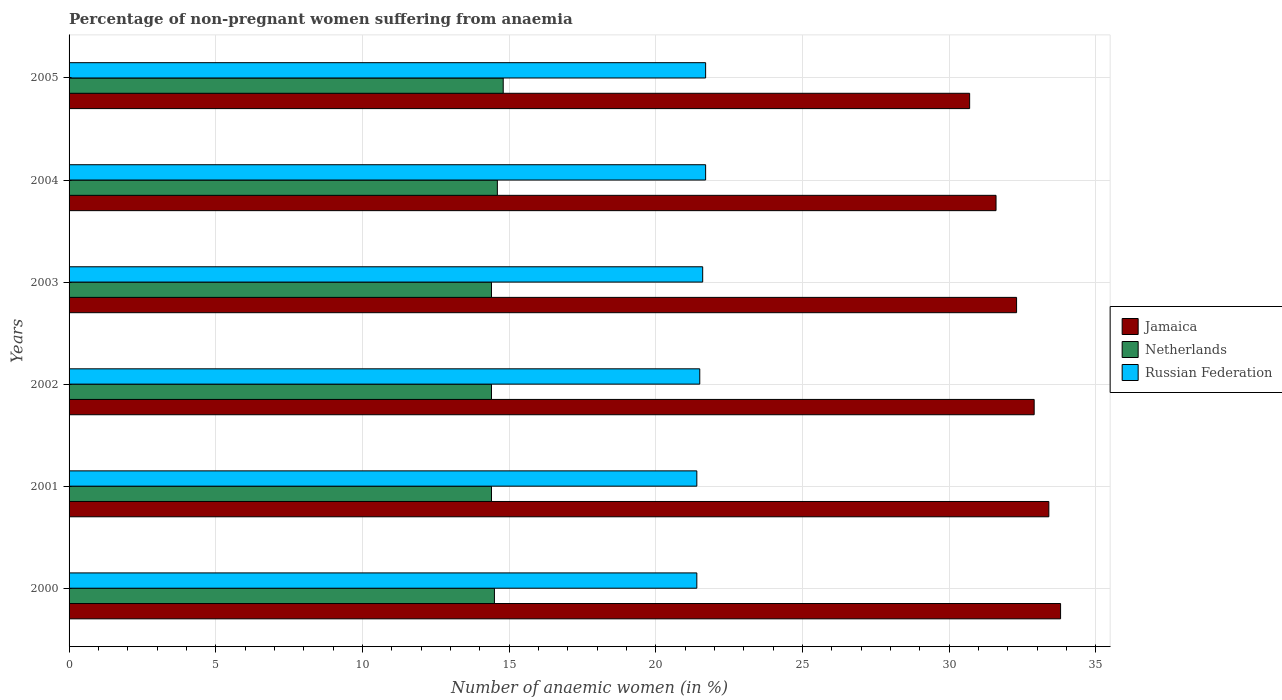How many groups of bars are there?
Provide a succinct answer. 6. What is the label of the 3rd group of bars from the top?
Give a very brief answer. 2003. In how many cases, is the number of bars for a given year not equal to the number of legend labels?
Offer a terse response. 0. What is the percentage of non-pregnant women suffering from anaemia in Jamaica in 2003?
Give a very brief answer. 32.3. Across all years, what is the minimum percentage of non-pregnant women suffering from anaemia in Russian Federation?
Your answer should be very brief. 21.4. In which year was the percentage of non-pregnant women suffering from anaemia in Netherlands maximum?
Make the answer very short. 2005. In which year was the percentage of non-pregnant women suffering from anaemia in Russian Federation minimum?
Keep it short and to the point. 2000. What is the total percentage of non-pregnant women suffering from anaemia in Netherlands in the graph?
Provide a short and direct response. 87.1. What is the difference between the percentage of non-pregnant women suffering from anaemia in Russian Federation in 2002 and that in 2005?
Offer a very short reply. -0.2. What is the difference between the percentage of non-pregnant women suffering from anaemia in Russian Federation in 2005 and the percentage of non-pregnant women suffering from anaemia in Netherlands in 2001?
Your answer should be very brief. 7.3. What is the average percentage of non-pregnant women suffering from anaemia in Russian Federation per year?
Keep it short and to the point. 21.55. In the year 2002, what is the difference between the percentage of non-pregnant women suffering from anaemia in Russian Federation and percentage of non-pregnant women suffering from anaemia in Netherlands?
Your answer should be compact. 7.1. What is the ratio of the percentage of non-pregnant women suffering from anaemia in Netherlands in 2000 to that in 2004?
Your answer should be compact. 0.99. Is the percentage of non-pregnant women suffering from anaemia in Jamaica in 2000 less than that in 2005?
Your response must be concise. No. Is the difference between the percentage of non-pregnant women suffering from anaemia in Russian Federation in 2002 and 2003 greater than the difference between the percentage of non-pregnant women suffering from anaemia in Netherlands in 2002 and 2003?
Provide a short and direct response. No. What is the difference between the highest and the second highest percentage of non-pregnant women suffering from anaemia in Netherlands?
Your response must be concise. 0.2. What is the difference between the highest and the lowest percentage of non-pregnant women suffering from anaemia in Jamaica?
Provide a succinct answer. 3.1. In how many years, is the percentage of non-pregnant women suffering from anaemia in Russian Federation greater than the average percentage of non-pregnant women suffering from anaemia in Russian Federation taken over all years?
Offer a terse response. 3. What does the 3rd bar from the bottom in 2001 represents?
Make the answer very short. Russian Federation. Is it the case that in every year, the sum of the percentage of non-pregnant women suffering from anaemia in Netherlands and percentage of non-pregnant women suffering from anaemia in Jamaica is greater than the percentage of non-pregnant women suffering from anaemia in Russian Federation?
Offer a terse response. Yes. How many bars are there?
Give a very brief answer. 18. How many years are there in the graph?
Provide a short and direct response. 6. What is the difference between two consecutive major ticks on the X-axis?
Offer a very short reply. 5. What is the title of the graph?
Your answer should be very brief. Percentage of non-pregnant women suffering from anaemia. What is the label or title of the X-axis?
Your response must be concise. Number of anaemic women (in %). What is the Number of anaemic women (in %) in Jamaica in 2000?
Provide a succinct answer. 33.8. What is the Number of anaemic women (in %) in Netherlands in 2000?
Your answer should be very brief. 14.5. What is the Number of anaemic women (in %) in Russian Federation in 2000?
Offer a very short reply. 21.4. What is the Number of anaemic women (in %) of Jamaica in 2001?
Offer a very short reply. 33.4. What is the Number of anaemic women (in %) in Russian Federation in 2001?
Give a very brief answer. 21.4. What is the Number of anaemic women (in %) of Jamaica in 2002?
Give a very brief answer. 32.9. What is the Number of anaemic women (in %) in Netherlands in 2002?
Your response must be concise. 14.4. What is the Number of anaemic women (in %) in Russian Federation in 2002?
Your answer should be compact. 21.5. What is the Number of anaemic women (in %) of Jamaica in 2003?
Ensure brevity in your answer.  32.3. What is the Number of anaemic women (in %) of Netherlands in 2003?
Your answer should be very brief. 14.4. What is the Number of anaemic women (in %) in Russian Federation in 2003?
Keep it short and to the point. 21.6. What is the Number of anaemic women (in %) of Jamaica in 2004?
Your answer should be compact. 31.6. What is the Number of anaemic women (in %) in Netherlands in 2004?
Offer a very short reply. 14.6. What is the Number of anaemic women (in %) in Russian Federation in 2004?
Provide a short and direct response. 21.7. What is the Number of anaemic women (in %) of Jamaica in 2005?
Offer a very short reply. 30.7. What is the Number of anaemic women (in %) in Netherlands in 2005?
Your response must be concise. 14.8. What is the Number of anaemic women (in %) in Russian Federation in 2005?
Your answer should be compact. 21.7. Across all years, what is the maximum Number of anaemic women (in %) of Jamaica?
Your answer should be compact. 33.8. Across all years, what is the maximum Number of anaemic women (in %) in Russian Federation?
Your answer should be compact. 21.7. Across all years, what is the minimum Number of anaemic women (in %) in Jamaica?
Provide a succinct answer. 30.7. Across all years, what is the minimum Number of anaemic women (in %) in Netherlands?
Your response must be concise. 14.4. Across all years, what is the minimum Number of anaemic women (in %) in Russian Federation?
Your answer should be very brief. 21.4. What is the total Number of anaemic women (in %) in Jamaica in the graph?
Make the answer very short. 194.7. What is the total Number of anaemic women (in %) of Netherlands in the graph?
Give a very brief answer. 87.1. What is the total Number of anaemic women (in %) in Russian Federation in the graph?
Your answer should be compact. 129.3. What is the difference between the Number of anaemic women (in %) in Russian Federation in 2000 and that in 2001?
Keep it short and to the point. 0. What is the difference between the Number of anaemic women (in %) in Jamaica in 2000 and that in 2003?
Your answer should be very brief. 1.5. What is the difference between the Number of anaemic women (in %) in Netherlands in 2000 and that in 2003?
Offer a terse response. 0.1. What is the difference between the Number of anaemic women (in %) of Jamaica in 2000 and that in 2004?
Provide a short and direct response. 2.2. What is the difference between the Number of anaemic women (in %) of Netherlands in 2000 and that in 2004?
Ensure brevity in your answer.  -0.1. What is the difference between the Number of anaemic women (in %) of Russian Federation in 2000 and that in 2004?
Offer a very short reply. -0.3. What is the difference between the Number of anaemic women (in %) of Russian Federation in 2000 and that in 2005?
Offer a terse response. -0.3. What is the difference between the Number of anaemic women (in %) of Jamaica in 2001 and that in 2002?
Your answer should be very brief. 0.5. What is the difference between the Number of anaemic women (in %) of Netherlands in 2001 and that in 2002?
Provide a short and direct response. 0. What is the difference between the Number of anaemic women (in %) in Netherlands in 2001 and that in 2003?
Offer a very short reply. 0. What is the difference between the Number of anaemic women (in %) of Russian Federation in 2001 and that in 2003?
Give a very brief answer. -0.2. What is the difference between the Number of anaemic women (in %) of Jamaica in 2001 and that in 2004?
Your response must be concise. 1.8. What is the difference between the Number of anaemic women (in %) in Netherlands in 2001 and that in 2004?
Ensure brevity in your answer.  -0.2. What is the difference between the Number of anaemic women (in %) of Russian Federation in 2001 and that in 2004?
Provide a short and direct response. -0.3. What is the difference between the Number of anaemic women (in %) of Jamaica in 2001 and that in 2005?
Offer a very short reply. 2.7. What is the difference between the Number of anaemic women (in %) in Netherlands in 2001 and that in 2005?
Offer a terse response. -0.4. What is the difference between the Number of anaemic women (in %) of Jamaica in 2002 and that in 2004?
Your answer should be very brief. 1.3. What is the difference between the Number of anaemic women (in %) of Jamaica in 2002 and that in 2005?
Your answer should be very brief. 2.2. What is the difference between the Number of anaemic women (in %) in Jamaica in 2003 and that in 2004?
Your answer should be very brief. 0.7. What is the difference between the Number of anaemic women (in %) in Russian Federation in 2003 and that in 2004?
Keep it short and to the point. -0.1. What is the difference between the Number of anaemic women (in %) in Jamaica in 2003 and that in 2005?
Your answer should be compact. 1.6. What is the difference between the Number of anaemic women (in %) in Netherlands in 2003 and that in 2005?
Your answer should be compact. -0.4. What is the difference between the Number of anaemic women (in %) of Jamaica in 2004 and that in 2005?
Keep it short and to the point. 0.9. What is the difference between the Number of anaemic women (in %) in Netherlands in 2004 and that in 2005?
Ensure brevity in your answer.  -0.2. What is the difference between the Number of anaemic women (in %) in Russian Federation in 2004 and that in 2005?
Offer a terse response. 0. What is the difference between the Number of anaemic women (in %) of Jamaica in 2000 and the Number of anaemic women (in %) of Netherlands in 2001?
Make the answer very short. 19.4. What is the difference between the Number of anaemic women (in %) in Jamaica in 2000 and the Number of anaemic women (in %) in Russian Federation in 2001?
Give a very brief answer. 12.4. What is the difference between the Number of anaemic women (in %) in Netherlands in 2000 and the Number of anaemic women (in %) in Russian Federation in 2001?
Give a very brief answer. -6.9. What is the difference between the Number of anaemic women (in %) in Jamaica in 2000 and the Number of anaemic women (in %) in Russian Federation in 2002?
Provide a short and direct response. 12.3. What is the difference between the Number of anaemic women (in %) of Jamaica in 2000 and the Number of anaemic women (in %) of Russian Federation in 2003?
Your answer should be compact. 12.2. What is the difference between the Number of anaemic women (in %) in Netherlands in 2000 and the Number of anaemic women (in %) in Russian Federation in 2003?
Make the answer very short. -7.1. What is the difference between the Number of anaemic women (in %) of Jamaica in 2000 and the Number of anaemic women (in %) of Netherlands in 2004?
Make the answer very short. 19.2. What is the difference between the Number of anaemic women (in %) of Jamaica in 2000 and the Number of anaemic women (in %) of Russian Federation in 2005?
Your answer should be compact. 12.1. What is the difference between the Number of anaemic women (in %) of Netherlands in 2000 and the Number of anaemic women (in %) of Russian Federation in 2005?
Ensure brevity in your answer.  -7.2. What is the difference between the Number of anaemic women (in %) in Jamaica in 2001 and the Number of anaemic women (in %) in Russian Federation in 2002?
Provide a short and direct response. 11.9. What is the difference between the Number of anaemic women (in %) in Jamaica in 2001 and the Number of anaemic women (in %) in Russian Federation in 2003?
Make the answer very short. 11.8. What is the difference between the Number of anaemic women (in %) of Netherlands in 2001 and the Number of anaemic women (in %) of Russian Federation in 2003?
Your answer should be very brief. -7.2. What is the difference between the Number of anaemic women (in %) in Jamaica in 2001 and the Number of anaemic women (in %) in Russian Federation in 2004?
Provide a short and direct response. 11.7. What is the difference between the Number of anaemic women (in %) of Jamaica in 2001 and the Number of anaemic women (in %) of Netherlands in 2005?
Your answer should be very brief. 18.6. What is the difference between the Number of anaemic women (in %) in Jamaica in 2001 and the Number of anaemic women (in %) in Russian Federation in 2005?
Provide a succinct answer. 11.7. What is the difference between the Number of anaemic women (in %) in Netherlands in 2001 and the Number of anaemic women (in %) in Russian Federation in 2005?
Ensure brevity in your answer.  -7.3. What is the difference between the Number of anaemic women (in %) in Jamaica in 2002 and the Number of anaemic women (in %) in Netherlands in 2003?
Keep it short and to the point. 18.5. What is the difference between the Number of anaemic women (in %) in Jamaica in 2002 and the Number of anaemic women (in %) in Russian Federation in 2003?
Give a very brief answer. 11.3. What is the difference between the Number of anaemic women (in %) of Netherlands in 2002 and the Number of anaemic women (in %) of Russian Federation in 2003?
Your answer should be compact. -7.2. What is the difference between the Number of anaemic women (in %) in Jamaica in 2002 and the Number of anaemic women (in %) in Netherlands in 2004?
Provide a short and direct response. 18.3. What is the difference between the Number of anaemic women (in %) in Jamaica in 2002 and the Number of anaemic women (in %) in Russian Federation in 2004?
Make the answer very short. 11.2. What is the difference between the Number of anaemic women (in %) of Netherlands in 2002 and the Number of anaemic women (in %) of Russian Federation in 2004?
Offer a terse response. -7.3. What is the difference between the Number of anaemic women (in %) of Netherlands in 2002 and the Number of anaemic women (in %) of Russian Federation in 2005?
Offer a terse response. -7.3. What is the difference between the Number of anaemic women (in %) of Jamaica in 2003 and the Number of anaemic women (in %) of Russian Federation in 2005?
Offer a very short reply. 10.6. What is the difference between the Number of anaemic women (in %) in Netherlands in 2003 and the Number of anaemic women (in %) in Russian Federation in 2005?
Your answer should be very brief. -7.3. What is the difference between the Number of anaemic women (in %) in Jamaica in 2004 and the Number of anaemic women (in %) in Netherlands in 2005?
Ensure brevity in your answer.  16.8. What is the difference between the Number of anaemic women (in %) of Netherlands in 2004 and the Number of anaemic women (in %) of Russian Federation in 2005?
Offer a terse response. -7.1. What is the average Number of anaemic women (in %) in Jamaica per year?
Give a very brief answer. 32.45. What is the average Number of anaemic women (in %) of Netherlands per year?
Make the answer very short. 14.52. What is the average Number of anaemic women (in %) of Russian Federation per year?
Your response must be concise. 21.55. In the year 2000, what is the difference between the Number of anaemic women (in %) of Jamaica and Number of anaemic women (in %) of Netherlands?
Offer a terse response. 19.3. In the year 2000, what is the difference between the Number of anaemic women (in %) of Netherlands and Number of anaemic women (in %) of Russian Federation?
Ensure brevity in your answer.  -6.9. In the year 2001, what is the difference between the Number of anaemic women (in %) of Jamaica and Number of anaemic women (in %) of Russian Federation?
Make the answer very short. 12. In the year 2001, what is the difference between the Number of anaemic women (in %) in Netherlands and Number of anaemic women (in %) in Russian Federation?
Your response must be concise. -7. In the year 2002, what is the difference between the Number of anaemic women (in %) of Netherlands and Number of anaemic women (in %) of Russian Federation?
Ensure brevity in your answer.  -7.1. In the year 2004, what is the difference between the Number of anaemic women (in %) of Netherlands and Number of anaemic women (in %) of Russian Federation?
Provide a succinct answer. -7.1. In the year 2005, what is the difference between the Number of anaemic women (in %) of Jamaica and Number of anaemic women (in %) of Netherlands?
Offer a very short reply. 15.9. In the year 2005, what is the difference between the Number of anaemic women (in %) in Netherlands and Number of anaemic women (in %) in Russian Federation?
Offer a terse response. -6.9. What is the ratio of the Number of anaemic women (in %) of Jamaica in 2000 to that in 2001?
Your response must be concise. 1.01. What is the ratio of the Number of anaemic women (in %) of Jamaica in 2000 to that in 2002?
Your answer should be compact. 1.03. What is the ratio of the Number of anaemic women (in %) in Russian Federation in 2000 to that in 2002?
Offer a very short reply. 1. What is the ratio of the Number of anaemic women (in %) of Jamaica in 2000 to that in 2003?
Provide a succinct answer. 1.05. What is the ratio of the Number of anaemic women (in %) of Netherlands in 2000 to that in 2003?
Give a very brief answer. 1.01. What is the ratio of the Number of anaemic women (in %) in Russian Federation in 2000 to that in 2003?
Your answer should be very brief. 0.99. What is the ratio of the Number of anaemic women (in %) of Jamaica in 2000 to that in 2004?
Give a very brief answer. 1.07. What is the ratio of the Number of anaemic women (in %) of Russian Federation in 2000 to that in 2004?
Keep it short and to the point. 0.99. What is the ratio of the Number of anaemic women (in %) in Jamaica in 2000 to that in 2005?
Offer a very short reply. 1.1. What is the ratio of the Number of anaemic women (in %) in Netherlands in 2000 to that in 2005?
Your response must be concise. 0.98. What is the ratio of the Number of anaemic women (in %) of Russian Federation in 2000 to that in 2005?
Provide a succinct answer. 0.99. What is the ratio of the Number of anaemic women (in %) of Jamaica in 2001 to that in 2002?
Provide a short and direct response. 1.02. What is the ratio of the Number of anaemic women (in %) of Russian Federation in 2001 to that in 2002?
Your response must be concise. 1. What is the ratio of the Number of anaemic women (in %) in Jamaica in 2001 to that in 2003?
Give a very brief answer. 1.03. What is the ratio of the Number of anaemic women (in %) of Jamaica in 2001 to that in 2004?
Provide a short and direct response. 1.06. What is the ratio of the Number of anaemic women (in %) in Netherlands in 2001 to that in 2004?
Make the answer very short. 0.99. What is the ratio of the Number of anaemic women (in %) of Russian Federation in 2001 to that in 2004?
Offer a terse response. 0.99. What is the ratio of the Number of anaemic women (in %) of Jamaica in 2001 to that in 2005?
Your response must be concise. 1.09. What is the ratio of the Number of anaemic women (in %) of Russian Federation in 2001 to that in 2005?
Your response must be concise. 0.99. What is the ratio of the Number of anaemic women (in %) in Jamaica in 2002 to that in 2003?
Give a very brief answer. 1.02. What is the ratio of the Number of anaemic women (in %) in Netherlands in 2002 to that in 2003?
Provide a short and direct response. 1. What is the ratio of the Number of anaemic women (in %) of Russian Federation in 2002 to that in 2003?
Offer a very short reply. 1. What is the ratio of the Number of anaemic women (in %) in Jamaica in 2002 to that in 2004?
Keep it short and to the point. 1.04. What is the ratio of the Number of anaemic women (in %) in Netherlands in 2002 to that in 2004?
Your answer should be compact. 0.99. What is the ratio of the Number of anaemic women (in %) of Russian Federation in 2002 to that in 2004?
Your response must be concise. 0.99. What is the ratio of the Number of anaemic women (in %) in Jamaica in 2002 to that in 2005?
Give a very brief answer. 1.07. What is the ratio of the Number of anaemic women (in %) of Russian Federation in 2002 to that in 2005?
Your answer should be compact. 0.99. What is the ratio of the Number of anaemic women (in %) of Jamaica in 2003 to that in 2004?
Your answer should be compact. 1.02. What is the ratio of the Number of anaemic women (in %) of Netherlands in 2003 to that in 2004?
Your answer should be compact. 0.99. What is the ratio of the Number of anaemic women (in %) in Jamaica in 2003 to that in 2005?
Make the answer very short. 1.05. What is the ratio of the Number of anaemic women (in %) of Jamaica in 2004 to that in 2005?
Give a very brief answer. 1.03. What is the ratio of the Number of anaemic women (in %) in Netherlands in 2004 to that in 2005?
Your answer should be compact. 0.99. What is the difference between the highest and the second highest Number of anaemic women (in %) in Jamaica?
Your answer should be compact. 0.4. What is the difference between the highest and the second highest Number of anaemic women (in %) of Russian Federation?
Your response must be concise. 0. What is the difference between the highest and the lowest Number of anaemic women (in %) of Jamaica?
Ensure brevity in your answer.  3.1. What is the difference between the highest and the lowest Number of anaemic women (in %) in Netherlands?
Provide a short and direct response. 0.4. What is the difference between the highest and the lowest Number of anaemic women (in %) of Russian Federation?
Give a very brief answer. 0.3. 